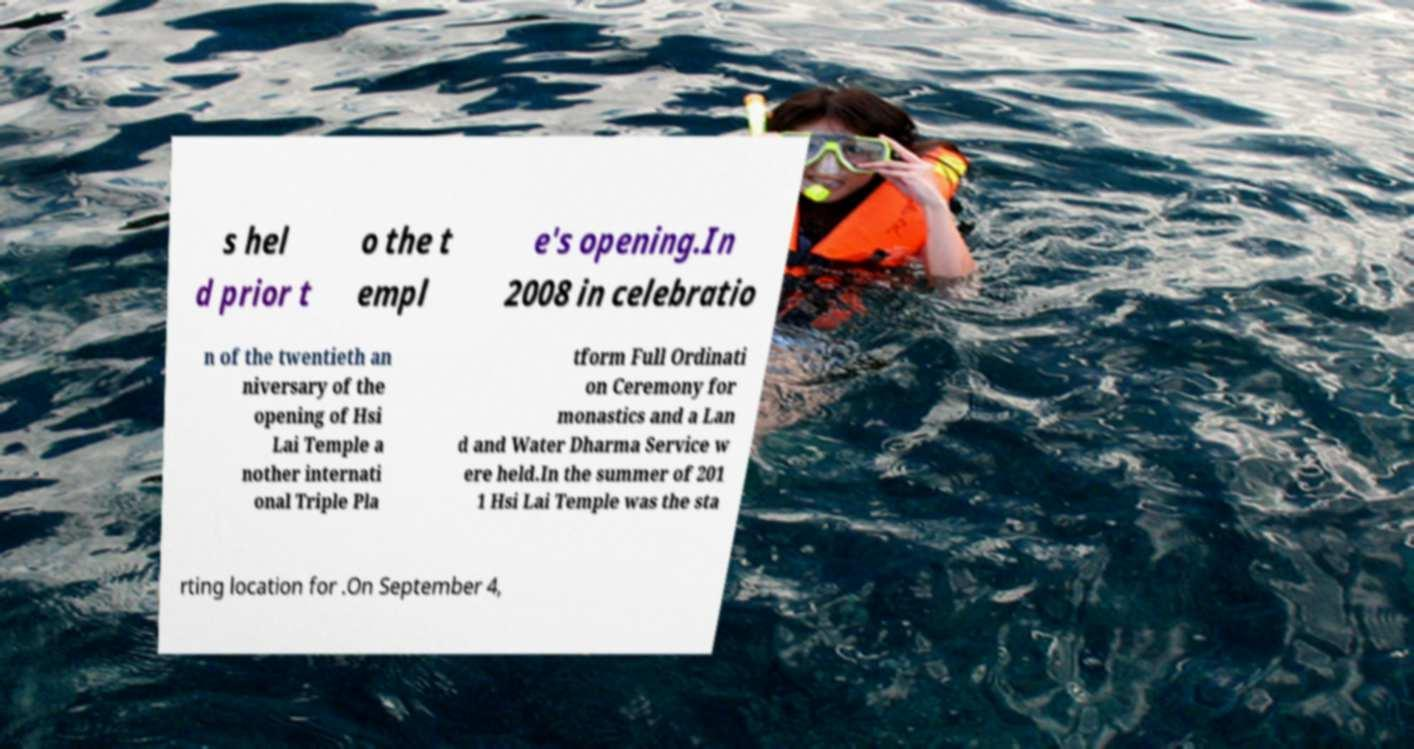Can you accurately transcribe the text from the provided image for me? s hel d prior t o the t empl e's opening.In 2008 in celebratio n of the twentieth an niversary of the opening of Hsi Lai Temple a nother internati onal Triple Pla tform Full Ordinati on Ceremony for monastics and a Lan d and Water Dharma Service w ere held.In the summer of 201 1 Hsi Lai Temple was the sta rting location for .On September 4, 